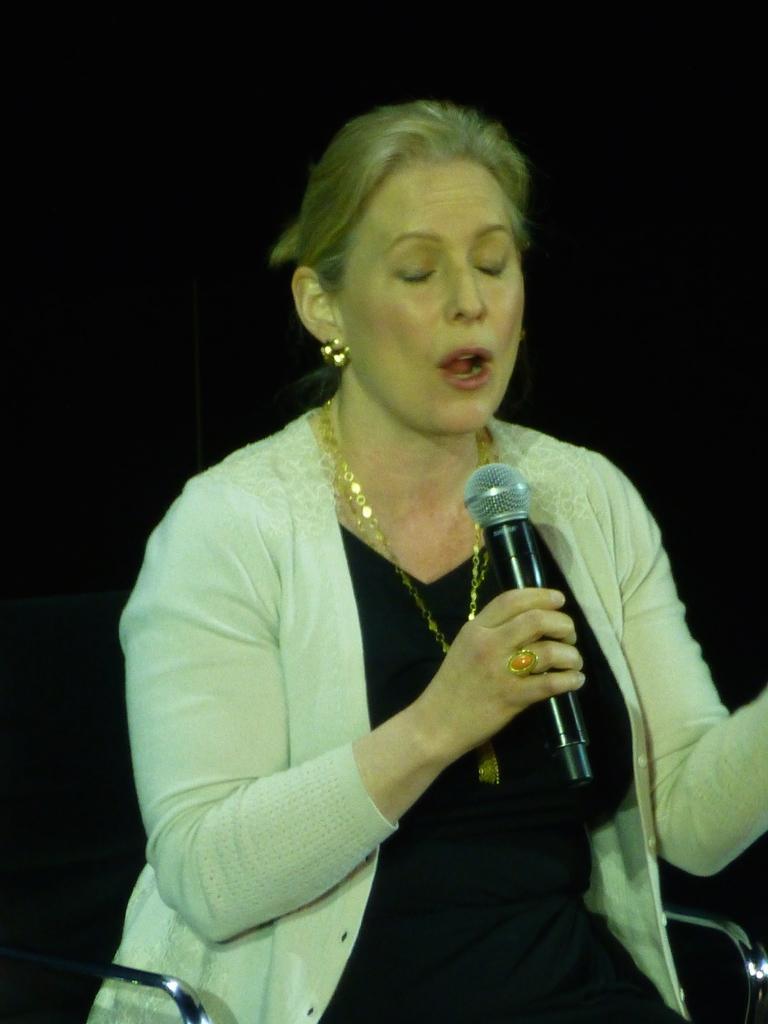In one or two sentences, can you explain what this image depicts? In this image, there is a person sitting on the chair and holding a mic with her hand. This person is wearing clothes and jewelry. 